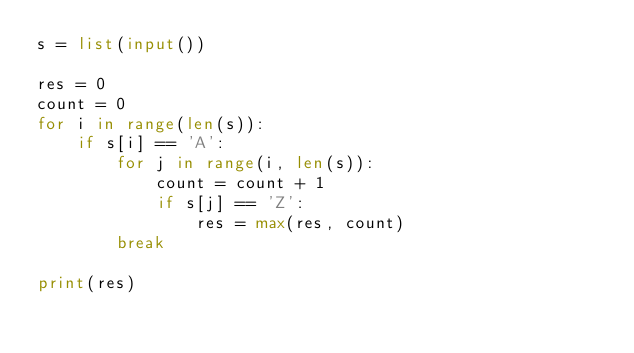Convert code to text. <code><loc_0><loc_0><loc_500><loc_500><_Python_>s = list(input())

res = 0
count = 0
for i in range(len(s)):
    if s[i] == 'A':
        for j in range(i, len(s)):
            count = count + 1
            if s[j] == 'Z':
                res = max(res, count)
        break

print(res)



</code> 